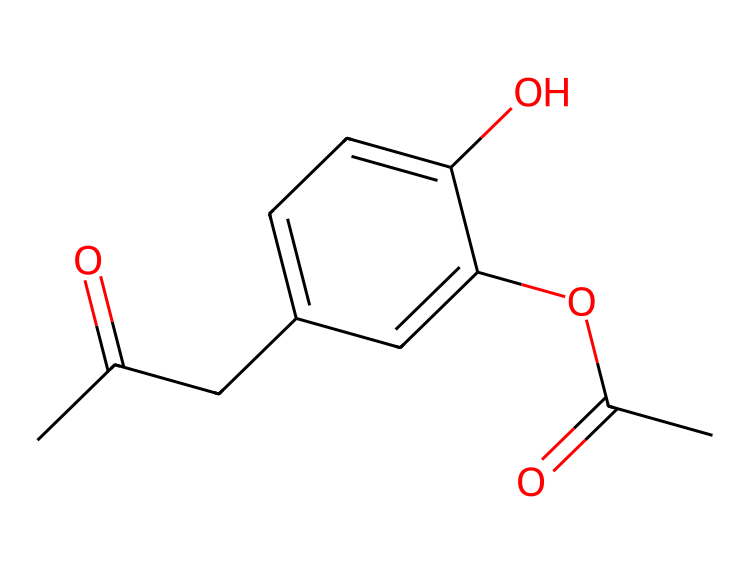What is the molecular formula of this compound? To find the molecular formula, count the number of each type of atom present in the structure. The structure indicates there are 15 carbon atoms, 16 hydrogen atoms, and 4 oxygen atoms. Hence, the molecular formula is C15H16O4.
Answer: C15H16O4 How many rings are present in this chemical structure? Analyzing the structure, it shows a phenolic ring and no other cyclic groups. Therefore, there is one ring present.
Answer: 1 What type of compound is represented by this structure? The presence of a phenolic group (indicated by the -OH) and additional functional groups, such as acetyl groups, suggests that this is an aromatic compound. Specifically, it is a type of flavonoid or polyphenol, known for anti-inflammatory properties.
Answer: aromatic Which functional group is indicated by the -OH in this structure? The -OH group is characteristic of hydroxyl functional groups, which are indicative of alcohols. This group significantly contributes to the compound's solubility and reactivity.
Answer: hydroxyl What effect do the acetyl groups have on the solubility of this compound? Acetyl groups typically increase solubility in polar solvents due to their carbonyl and methyl components. The presence of these groups likely enhances the compound's solubility in water.
Answer: increases What is one major biological activity associated with this compound? This chemical is known for its anti-inflammatory properties, which is attributed to its ability to inhibit certain inflammatory pathways in the body.
Answer: anti-inflammatory 